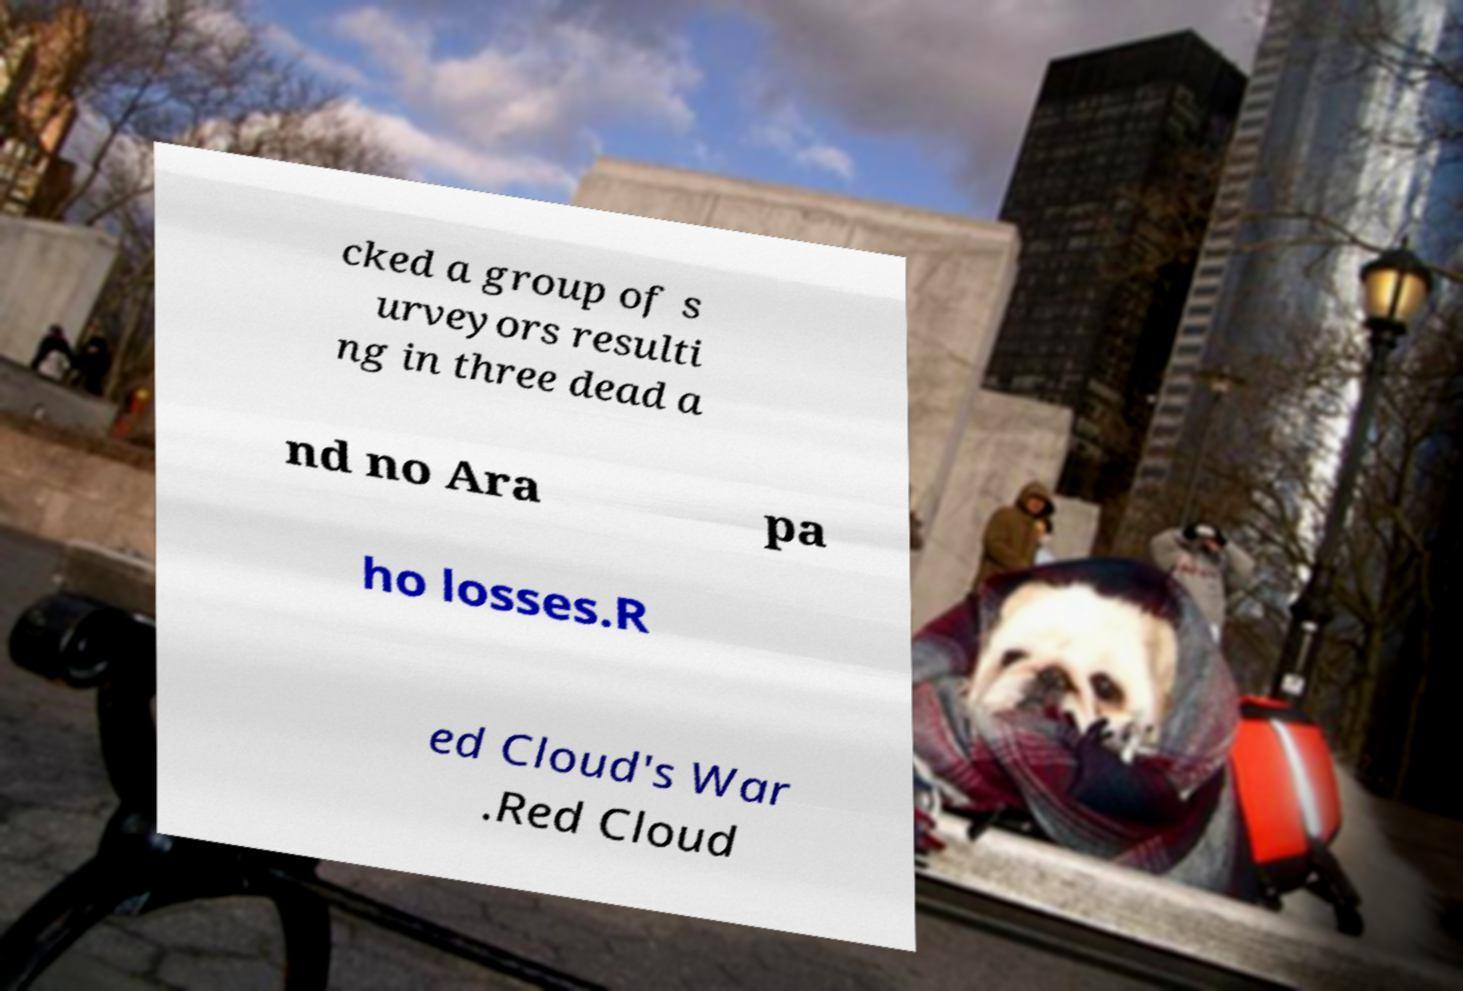Can you accurately transcribe the text from the provided image for me? cked a group of s urveyors resulti ng in three dead a nd no Ara pa ho losses.R ed Cloud's War .Red Cloud 